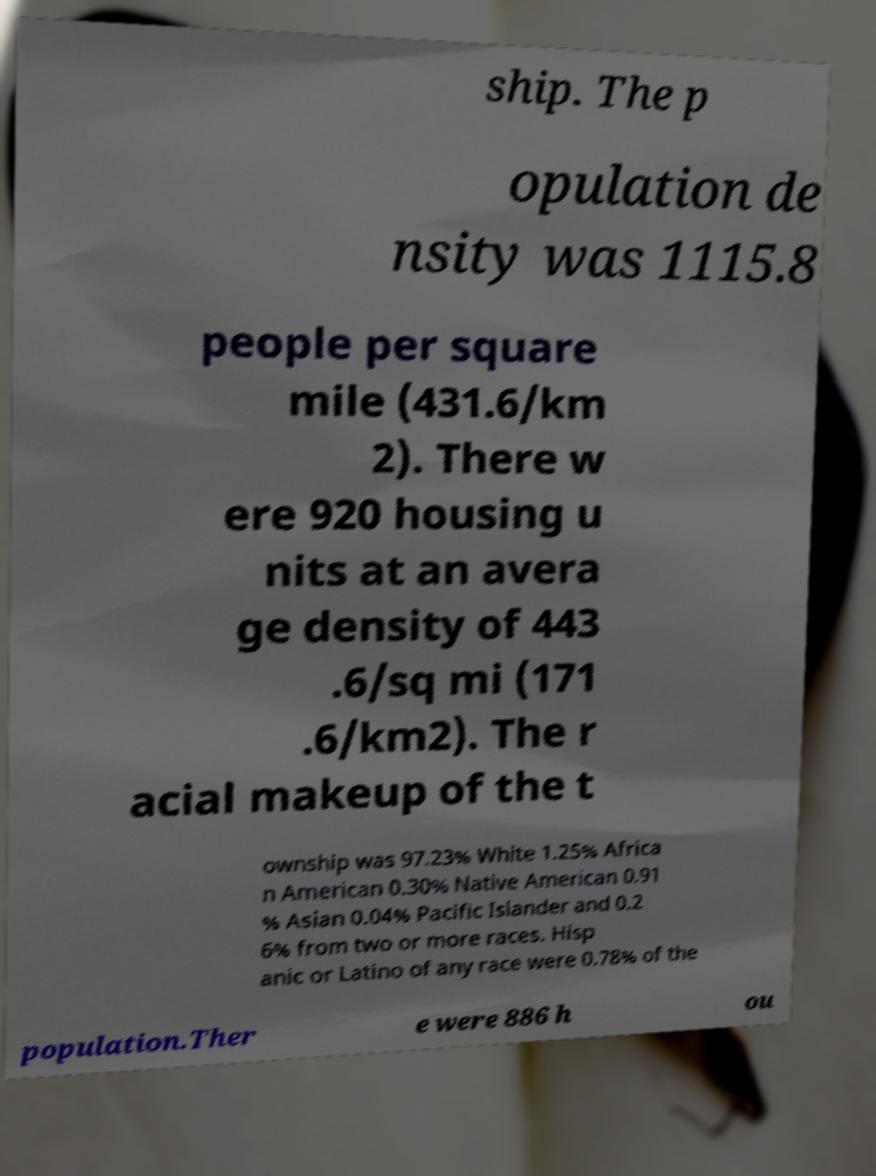What messages or text are displayed in this image? I need them in a readable, typed format. ship. The p opulation de nsity was 1115.8 people per square mile (431.6/km 2). There w ere 920 housing u nits at an avera ge density of 443 .6/sq mi (171 .6/km2). The r acial makeup of the t ownship was 97.23% White 1.25% Africa n American 0.30% Native American 0.91 % Asian 0.04% Pacific Islander and 0.2 6% from two or more races. Hisp anic or Latino of any race were 0.78% of the population.Ther e were 886 h ou 